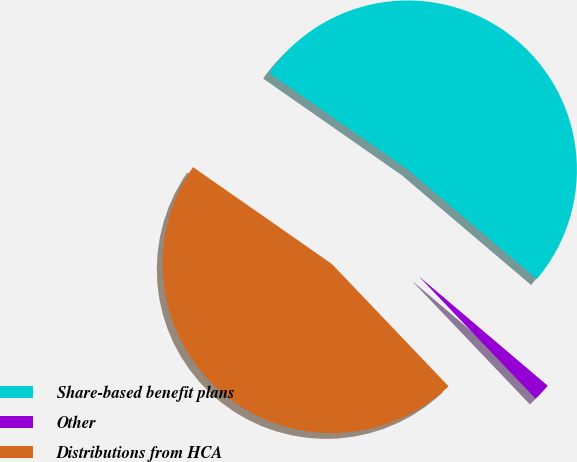<chart> <loc_0><loc_0><loc_500><loc_500><pie_chart><fcel>Share-based benefit plans<fcel>Other<fcel>Distributions from HCA<nl><fcel>51.51%<fcel>1.67%<fcel>46.82%<nl></chart> 